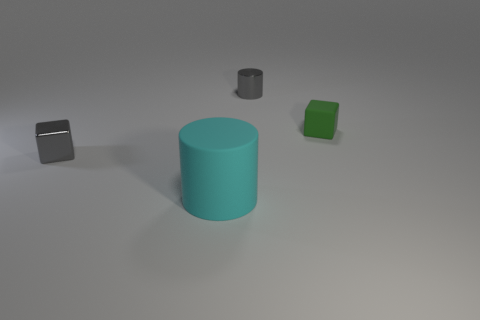What number of blocks are the same material as the large cyan thing?
Offer a very short reply. 1. There is a small metallic thing that is the same color as the small metallic block; what is its shape?
Ensure brevity in your answer.  Cylinder. What material is the tiny object that is to the left of the green block and to the right of the gray cube?
Your answer should be very brief. Metal. What is the shape of the big object left of the green cube?
Give a very brief answer. Cylinder. What shape is the tiny gray metallic thing right of the tiny block that is left of the big cyan thing?
Your answer should be very brief. Cylinder. Are there any tiny gray objects of the same shape as the small green matte object?
Your response must be concise. Yes. There is a green matte object that is the same size as the gray metal cylinder; what is its shape?
Your answer should be compact. Cube. There is a small gray thing that is behind the cube on the left side of the cyan object; is there a tiny green object on the right side of it?
Make the answer very short. Yes. Are there any shiny cylinders that have the same size as the green block?
Offer a terse response. Yes. There is a cube to the right of the big cyan matte cylinder; what size is it?
Offer a very short reply. Small. 